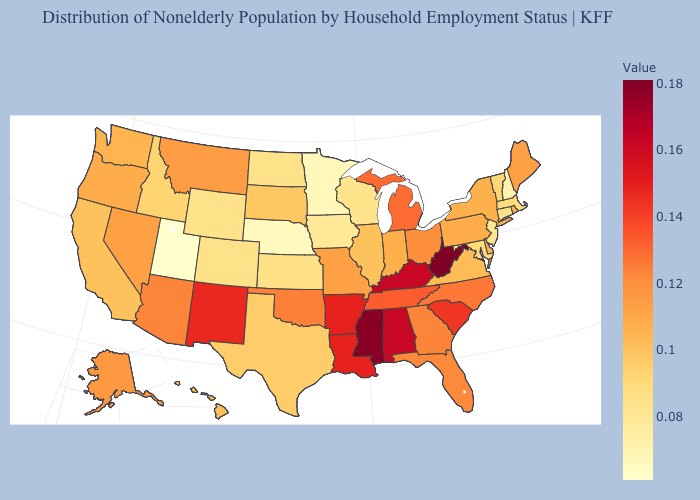Which states have the lowest value in the USA?
Be succinct. Utah. Does Alabama have a lower value than Mississippi?
Short answer required. Yes. Does Louisiana have a higher value than Georgia?
Write a very short answer. Yes. Does South Dakota have a lower value than Alaska?
Short answer required. Yes. Does the map have missing data?
Quick response, please. No. Which states have the lowest value in the USA?
Keep it brief. Utah. 